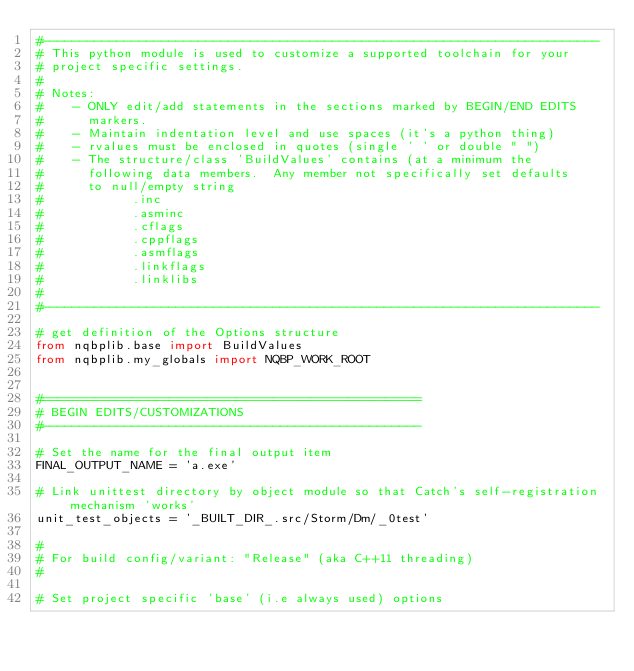<code> <loc_0><loc_0><loc_500><loc_500><_Python_>#---------------------------------------------------------------------------
# This python module is used to customize a supported toolchain for your 
# project specific settings.
#
# Notes:
#    - ONLY edit/add statements in the sections marked by BEGIN/END EDITS
#      markers.
#    - Maintain indentation level and use spaces (it's a python thing) 
#    - rvalues must be enclosed in quotes (single ' ' or double " ")
#    - The structure/class 'BuildValues' contains (at a minimum the
#      following data members.  Any member not specifically set defaults
#      to null/empty string
#            .inc 
#            .asminc
#            .cflags
#            .cppflags
#            .asmflags
#            .linkflags
#            .linklibs
#           
#---------------------------------------------------------------------------

# get definition of the Options structure
from nqbplib.base import BuildValues
from nqbplib.my_globals import NQBP_WORK_ROOT


#===================================================
# BEGIN EDITS/CUSTOMIZATIONS
#---------------------------------------------------

# Set the name for the final output item
FINAL_OUTPUT_NAME = 'a.exe'

# Link unittest directory by object module so that Catch's self-registration mechanism 'works'
unit_test_objects = '_BUILT_DIR_.src/Storm/Dm/_0test'

#
# For build config/variant: "Release" (aka C++11 threading)
#

# Set project specific 'base' (i.e always used) options</code> 